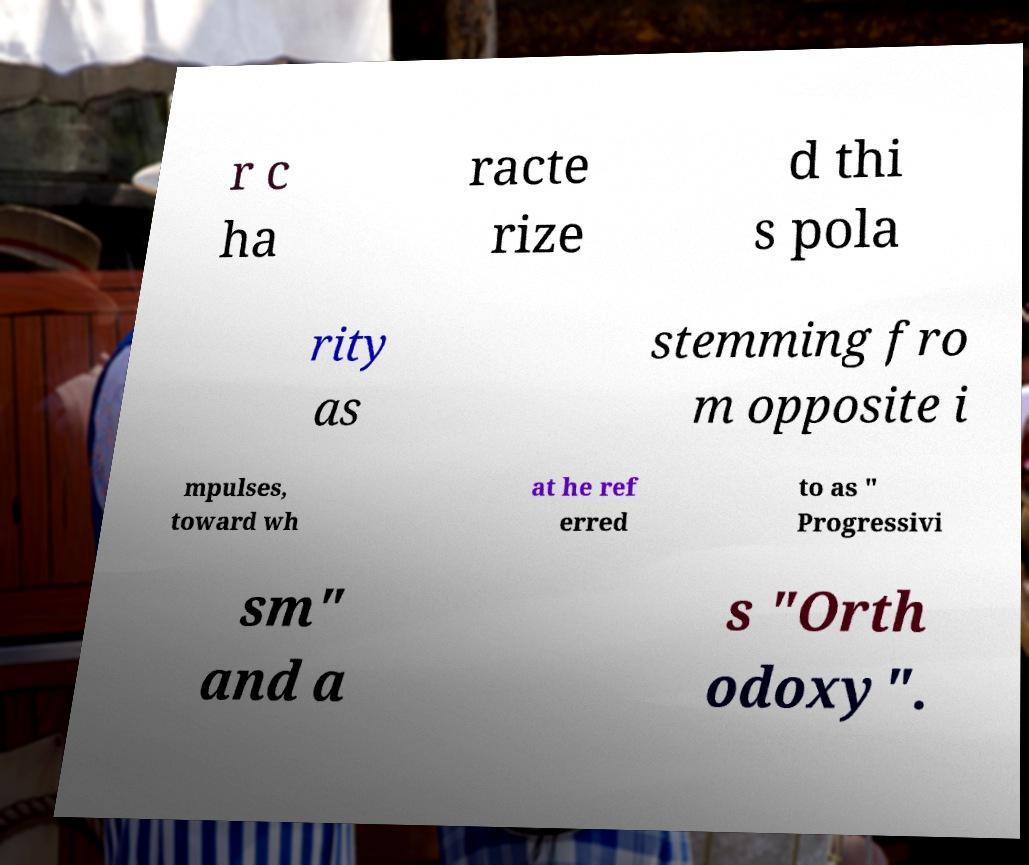Can you read and provide the text displayed in the image?This photo seems to have some interesting text. Can you extract and type it out for me? r c ha racte rize d thi s pola rity as stemming fro m opposite i mpulses, toward wh at he ref erred to as " Progressivi sm" and a s "Orth odoxy". 